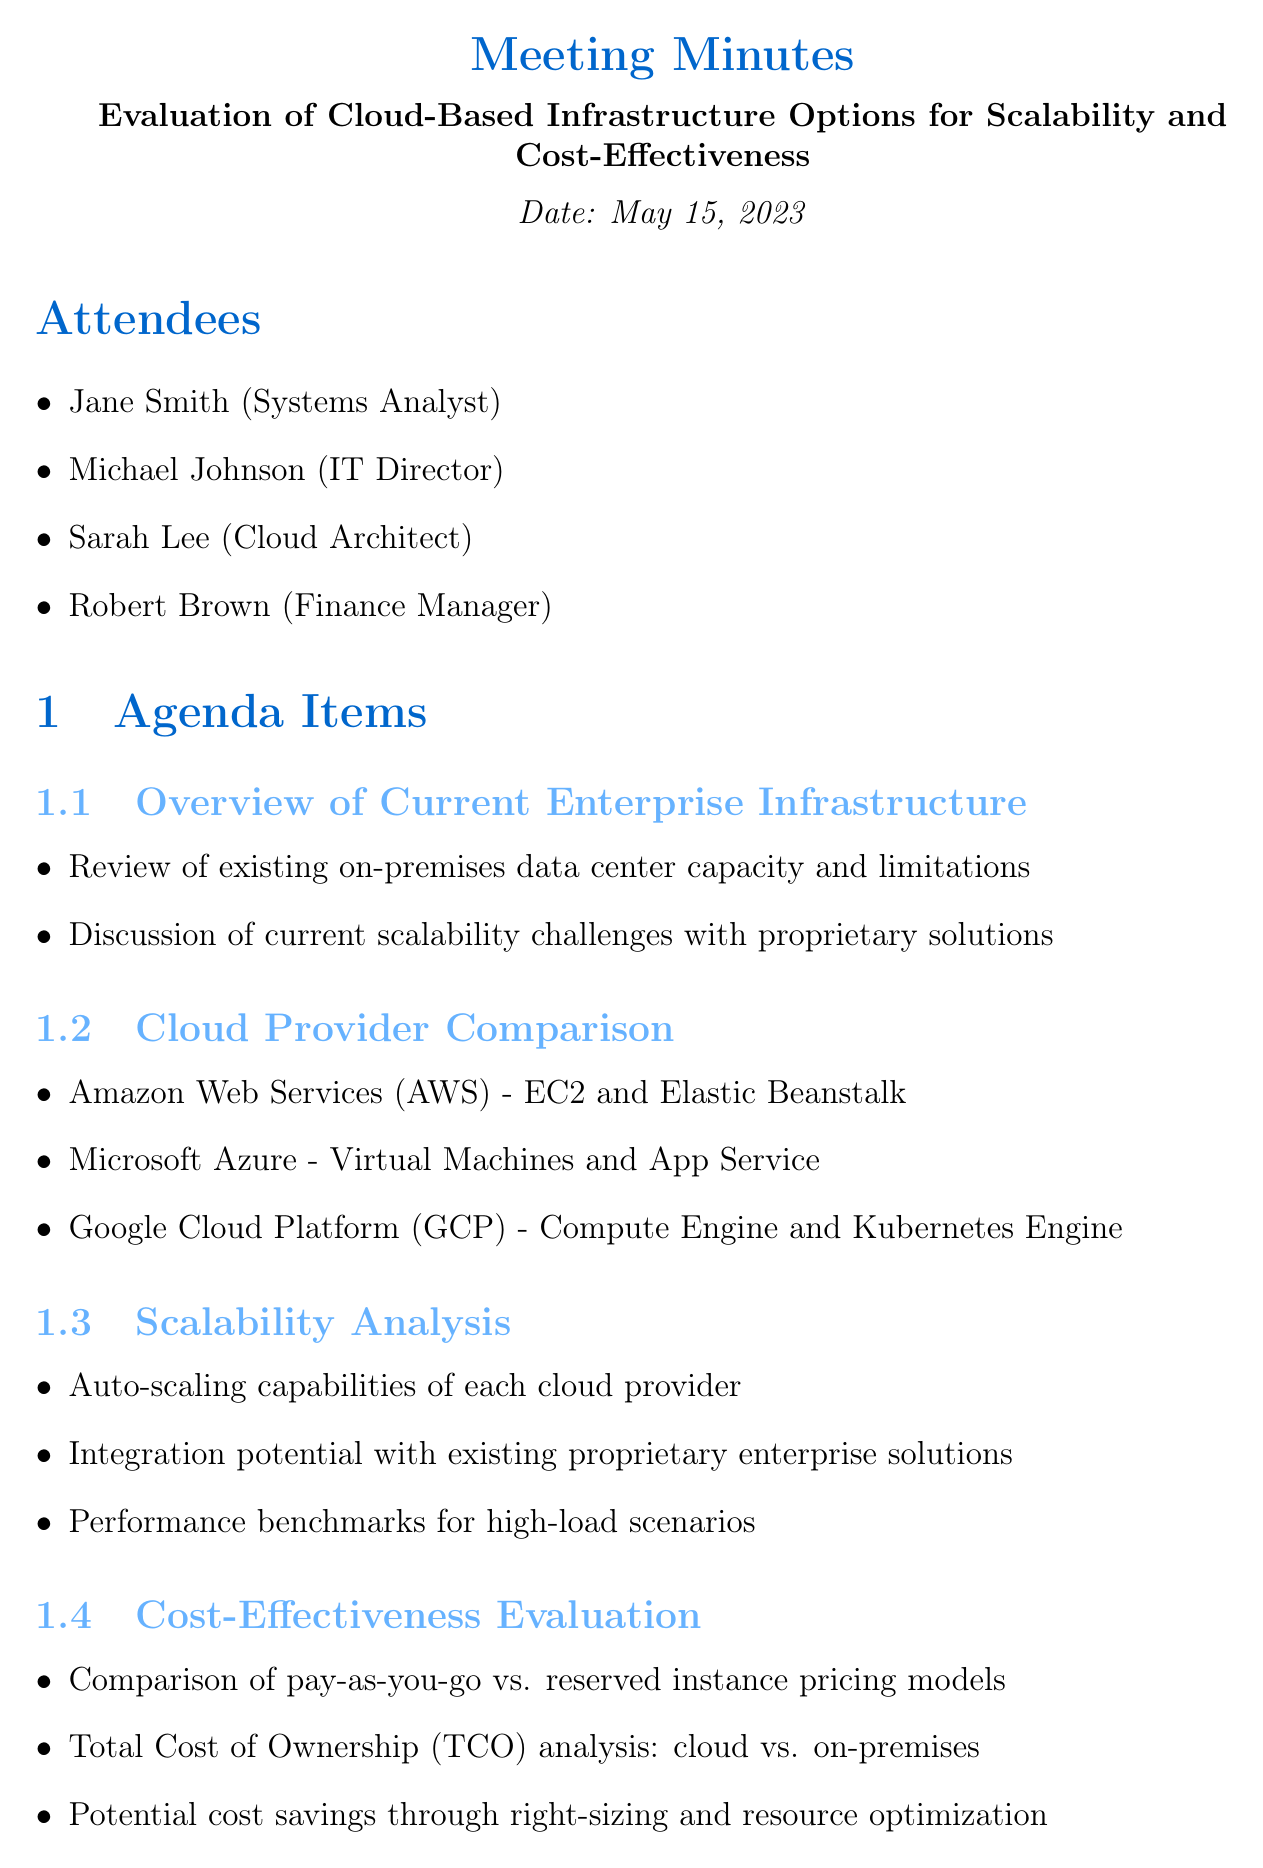What is the date of the meeting? The meeting was held on May 15, 2023, as stated at the top of the document.
Answer: May 15, 2023 Who is the IT Director attending the meeting? The attendees list includes Michael Johnson as the IT Director.
Answer: Michael Johnson What is one of the cloud providers discussed in the comparison? The document lists Amazon Web Services (AWS) as one of the cloud providers compared.
Answer: Amazon Web Services (AWS) What is the due date for creating the comparison matrix? The action item for creating the comparison matrix is due on May 29, 2023.
Answer: 2023-05-29 Which compliance regulation is mentioned in the security considerations? The document mentions GDPR as one of the industry regulations for compliance.
Answer: GDPR Which scalability feature was discussed with respect to cloud providers? The document mentions the auto-scaling capabilities of each cloud provider as a point of analysis.
Answer: Auto-scaling capabilities What is one of the next steps mentioned in the meeting? The document states that one of the next steps is to schedule proof-of-concept deployments for the top two cloud options.
Answer: Schedule proof-of-concept deployments Who is responsible for initiating discussions with cloud provider representatives? The action item lists Robert Brown as the assignee for initiating discussions with cloud provider representatives.
Answer: Robert Brown What type of pricing models were evaluated for cost-effectiveness? The evaluation included a comparison of pay-as-you-go vs. reserved instance pricing models.
Answer: Pay-as-you-go vs. reserved instance pricing models 